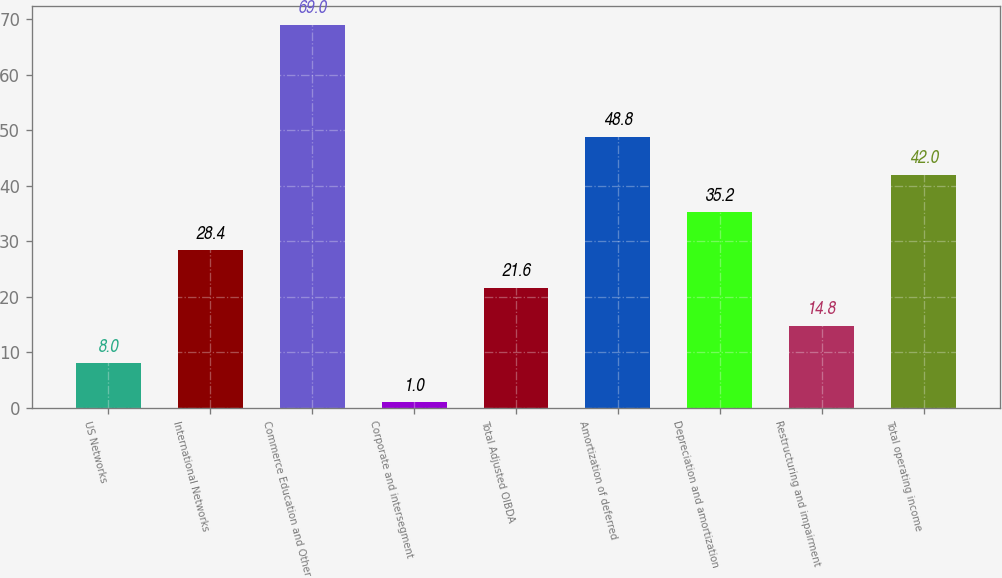<chart> <loc_0><loc_0><loc_500><loc_500><bar_chart><fcel>US Networks<fcel>International Networks<fcel>Commerce Education and Other<fcel>Corporate and intersegment<fcel>Total Adjusted OIBDA<fcel>Amortization of deferred<fcel>Depreciation and amortization<fcel>Restructuring and impairment<fcel>Total operating income<nl><fcel>8<fcel>28.4<fcel>69<fcel>1<fcel>21.6<fcel>48.8<fcel>35.2<fcel>14.8<fcel>42<nl></chart> 